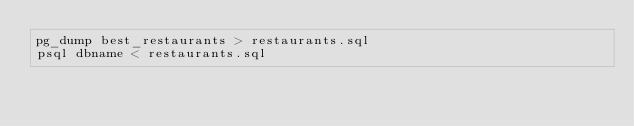<code> <loc_0><loc_0><loc_500><loc_500><_SQL_>pg_dump best_restaurants > restaurants.sql
psql dbname < restaurants.sql
</code> 